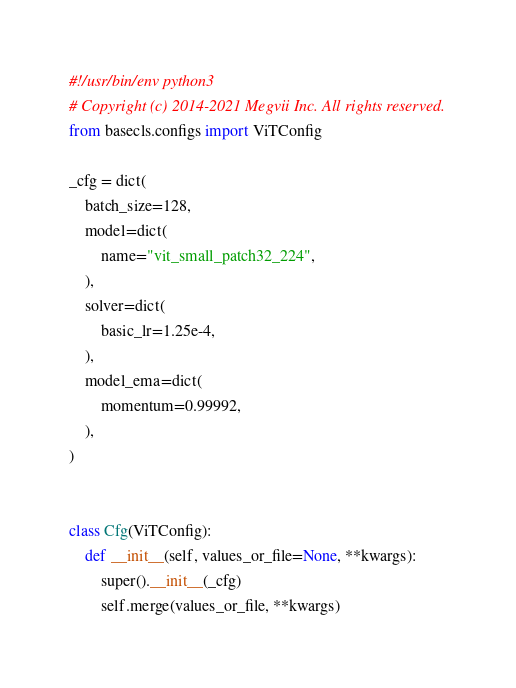<code> <loc_0><loc_0><loc_500><loc_500><_Python_>#!/usr/bin/env python3
# Copyright (c) 2014-2021 Megvii Inc. All rights reserved.
from basecls.configs import ViTConfig

_cfg = dict(
    batch_size=128,
    model=dict(
        name="vit_small_patch32_224",
    ),
    solver=dict(
        basic_lr=1.25e-4,
    ),
    model_ema=dict(
        momentum=0.99992,
    ),
)


class Cfg(ViTConfig):
    def __init__(self, values_or_file=None, **kwargs):
        super().__init__(_cfg)
        self.merge(values_or_file, **kwargs)
</code> 